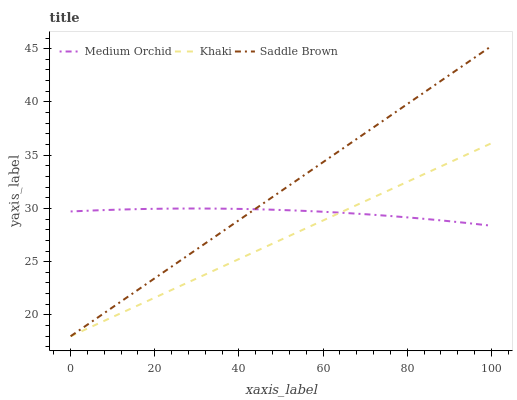Does Khaki have the minimum area under the curve?
Answer yes or no. Yes. Does Saddle Brown have the maximum area under the curve?
Answer yes or no. Yes. Does Saddle Brown have the minimum area under the curve?
Answer yes or no. No. Does Khaki have the maximum area under the curve?
Answer yes or no. No. Is Khaki the smoothest?
Answer yes or no. Yes. Is Medium Orchid the roughest?
Answer yes or no. Yes. Is Saddle Brown the smoothest?
Answer yes or no. No. Is Saddle Brown the roughest?
Answer yes or no. No. Does Khaki have the lowest value?
Answer yes or no. Yes. Does Saddle Brown have the highest value?
Answer yes or no. Yes. Does Khaki have the highest value?
Answer yes or no. No. Does Khaki intersect Medium Orchid?
Answer yes or no. Yes. Is Khaki less than Medium Orchid?
Answer yes or no. No. Is Khaki greater than Medium Orchid?
Answer yes or no. No. 